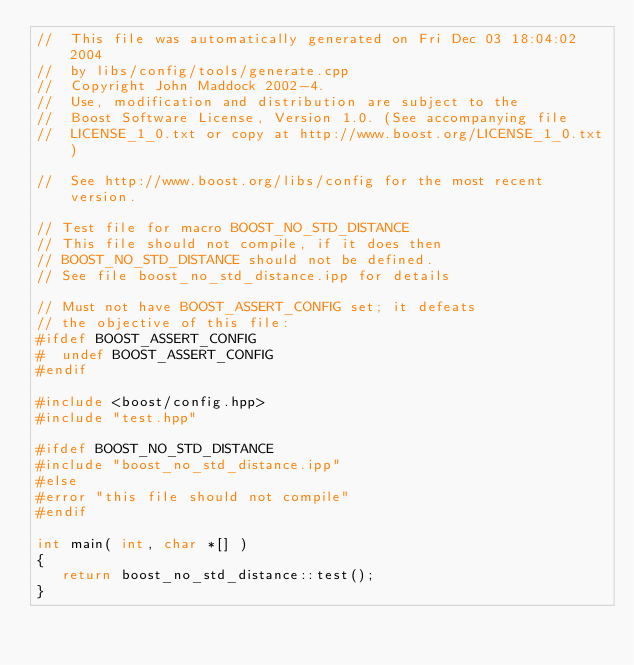Convert code to text. <code><loc_0><loc_0><loc_500><loc_500><_C++_>//  This file was automatically generated on Fri Dec 03 18:04:02 2004
//  by libs/config/tools/generate.cpp
//  Copyright John Maddock 2002-4.
//  Use, modification and distribution are subject to the
//  Boost Software License, Version 1.0. (See accompanying file
//  LICENSE_1_0.txt or copy at http://www.boost.org/LICENSE_1_0.txt)

//  See http://www.boost.org/libs/config for the most recent version.

// Test file for macro BOOST_NO_STD_DISTANCE
// This file should not compile, if it does then
// BOOST_NO_STD_DISTANCE should not be defined.
// See file boost_no_std_distance.ipp for details

// Must not have BOOST_ASSERT_CONFIG set; it defeats
// the objective of this file:
#ifdef BOOST_ASSERT_CONFIG
#  undef BOOST_ASSERT_CONFIG
#endif

#include <boost/config.hpp>
#include "test.hpp"

#ifdef BOOST_NO_STD_DISTANCE
#include "boost_no_std_distance.ipp"
#else
#error "this file should not compile"
#endif

int main( int, char *[] )
{
   return boost_no_std_distance::test();
}
</code> 